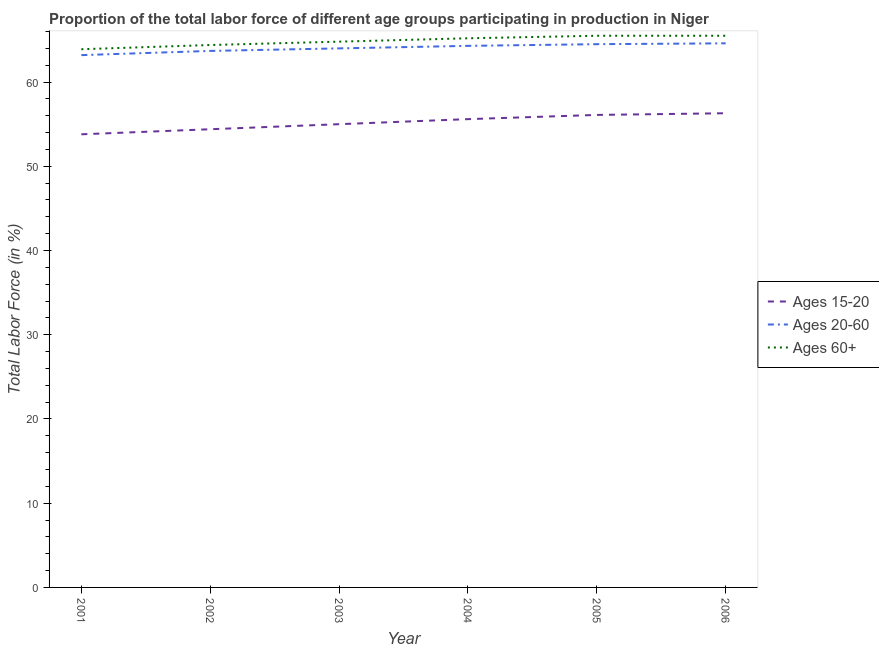Is the number of lines equal to the number of legend labels?
Make the answer very short. Yes. What is the percentage of labor force within the age group 20-60 in 2005?
Your answer should be very brief. 64.5. Across all years, what is the maximum percentage of labor force within the age group 15-20?
Your answer should be compact. 56.3. Across all years, what is the minimum percentage of labor force within the age group 15-20?
Provide a succinct answer. 53.8. In which year was the percentage of labor force above age 60 minimum?
Keep it short and to the point. 2001. What is the total percentage of labor force above age 60 in the graph?
Your response must be concise. 389.3. What is the difference between the percentage of labor force within the age group 20-60 in 2003 and that in 2005?
Make the answer very short. -0.5. What is the difference between the percentage of labor force within the age group 20-60 in 2001 and the percentage of labor force above age 60 in 2002?
Offer a very short reply. -1.2. What is the average percentage of labor force within the age group 15-20 per year?
Keep it short and to the point. 55.2. In the year 2001, what is the difference between the percentage of labor force within the age group 15-20 and percentage of labor force above age 60?
Keep it short and to the point. -10.1. What is the ratio of the percentage of labor force within the age group 20-60 in 2003 to that in 2006?
Your answer should be very brief. 0.99. Is the percentage of labor force above age 60 in 2003 less than that in 2004?
Your response must be concise. Yes. Is the difference between the percentage of labor force within the age group 15-20 in 2002 and 2003 greater than the difference between the percentage of labor force within the age group 20-60 in 2002 and 2003?
Keep it short and to the point. No. What is the difference between the highest and the second highest percentage of labor force within the age group 15-20?
Keep it short and to the point. 0.2. What is the difference between the highest and the lowest percentage of labor force above age 60?
Your answer should be compact. 1.6. Is it the case that in every year, the sum of the percentage of labor force within the age group 15-20 and percentage of labor force within the age group 20-60 is greater than the percentage of labor force above age 60?
Your response must be concise. Yes. Does the percentage of labor force above age 60 monotonically increase over the years?
Your answer should be compact. No. Is the percentage of labor force within the age group 20-60 strictly greater than the percentage of labor force within the age group 15-20 over the years?
Give a very brief answer. Yes. Is the percentage of labor force within the age group 15-20 strictly less than the percentage of labor force within the age group 20-60 over the years?
Offer a very short reply. Yes. Does the graph contain any zero values?
Ensure brevity in your answer.  No. Does the graph contain grids?
Give a very brief answer. No. How are the legend labels stacked?
Provide a succinct answer. Vertical. What is the title of the graph?
Offer a terse response. Proportion of the total labor force of different age groups participating in production in Niger. Does "Non-communicable diseases" appear as one of the legend labels in the graph?
Ensure brevity in your answer.  No. What is the Total Labor Force (in %) of Ages 15-20 in 2001?
Your answer should be very brief. 53.8. What is the Total Labor Force (in %) of Ages 20-60 in 2001?
Offer a very short reply. 63.2. What is the Total Labor Force (in %) in Ages 60+ in 2001?
Give a very brief answer. 63.9. What is the Total Labor Force (in %) of Ages 15-20 in 2002?
Ensure brevity in your answer.  54.4. What is the Total Labor Force (in %) of Ages 20-60 in 2002?
Your answer should be compact. 63.7. What is the Total Labor Force (in %) in Ages 60+ in 2002?
Your answer should be very brief. 64.4. What is the Total Labor Force (in %) in Ages 20-60 in 2003?
Provide a succinct answer. 64. What is the Total Labor Force (in %) of Ages 60+ in 2003?
Provide a short and direct response. 64.8. What is the Total Labor Force (in %) of Ages 15-20 in 2004?
Provide a short and direct response. 55.6. What is the Total Labor Force (in %) of Ages 20-60 in 2004?
Offer a very short reply. 64.3. What is the Total Labor Force (in %) in Ages 60+ in 2004?
Your answer should be very brief. 65.2. What is the Total Labor Force (in %) of Ages 15-20 in 2005?
Your answer should be compact. 56.1. What is the Total Labor Force (in %) of Ages 20-60 in 2005?
Keep it short and to the point. 64.5. What is the Total Labor Force (in %) in Ages 60+ in 2005?
Keep it short and to the point. 65.5. What is the Total Labor Force (in %) in Ages 15-20 in 2006?
Offer a very short reply. 56.3. What is the Total Labor Force (in %) of Ages 20-60 in 2006?
Offer a terse response. 64.6. What is the Total Labor Force (in %) of Ages 60+ in 2006?
Offer a terse response. 65.5. Across all years, what is the maximum Total Labor Force (in %) of Ages 15-20?
Your response must be concise. 56.3. Across all years, what is the maximum Total Labor Force (in %) of Ages 20-60?
Offer a very short reply. 64.6. Across all years, what is the maximum Total Labor Force (in %) of Ages 60+?
Give a very brief answer. 65.5. Across all years, what is the minimum Total Labor Force (in %) of Ages 15-20?
Your answer should be very brief. 53.8. Across all years, what is the minimum Total Labor Force (in %) of Ages 20-60?
Provide a short and direct response. 63.2. Across all years, what is the minimum Total Labor Force (in %) in Ages 60+?
Make the answer very short. 63.9. What is the total Total Labor Force (in %) in Ages 15-20 in the graph?
Provide a short and direct response. 331.2. What is the total Total Labor Force (in %) of Ages 20-60 in the graph?
Your answer should be compact. 384.3. What is the total Total Labor Force (in %) of Ages 60+ in the graph?
Provide a short and direct response. 389.3. What is the difference between the Total Labor Force (in %) of Ages 15-20 in 2001 and that in 2002?
Offer a terse response. -0.6. What is the difference between the Total Labor Force (in %) in Ages 20-60 in 2001 and that in 2002?
Give a very brief answer. -0.5. What is the difference between the Total Labor Force (in %) in Ages 60+ in 2001 and that in 2002?
Provide a succinct answer. -0.5. What is the difference between the Total Labor Force (in %) of Ages 15-20 in 2001 and that in 2003?
Offer a very short reply. -1.2. What is the difference between the Total Labor Force (in %) in Ages 20-60 in 2001 and that in 2003?
Provide a succinct answer. -0.8. What is the difference between the Total Labor Force (in %) of Ages 20-60 in 2001 and that in 2004?
Ensure brevity in your answer.  -1.1. What is the difference between the Total Labor Force (in %) of Ages 20-60 in 2001 and that in 2005?
Provide a short and direct response. -1.3. What is the difference between the Total Labor Force (in %) of Ages 60+ in 2001 and that in 2005?
Your answer should be compact. -1.6. What is the difference between the Total Labor Force (in %) of Ages 15-20 in 2001 and that in 2006?
Your response must be concise. -2.5. What is the difference between the Total Labor Force (in %) in Ages 60+ in 2001 and that in 2006?
Your answer should be very brief. -1.6. What is the difference between the Total Labor Force (in %) of Ages 20-60 in 2002 and that in 2003?
Provide a short and direct response. -0.3. What is the difference between the Total Labor Force (in %) of Ages 60+ in 2002 and that in 2003?
Make the answer very short. -0.4. What is the difference between the Total Labor Force (in %) in Ages 15-20 in 2002 and that in 2004?
Offer a very short reply. -1.2. What is the difference between the Total Labor Force (in %) of Ages 20-60 in 2002 and that in 2004?
Keep it short and to the point. -0.6. What is the difference between the Total Labor Force (in %) in Ages 15-20 in 2002 and that in 2006?
Ensure brevity in your answer.  -1.9. What is the difference between the Total Labor Force (in %) of Ages 60+ in 2002 and that in 2006?
Offer a terse response. -1.1. What is the difference between the Total Labor Force (in %) of Ages 15-20 in 2003 and that in 2004?
Your response must be concise. -0.6. What is the difference between the Total Labor Force (in %) of Ages 60+ in 2003 and that in 2004?
Offer a very short reply. -0.4. What is the difference between the Total Labor Force (in %) of Ages 60+ in 2003 and that in 2005?
Your answer should be very brief. -0.7. What is the difference between the Total Labor Force (in %) of Ages 20-60 in 2003 and that in 2006?
Offer a terse response. -0.6. What is the difference between the Total Labor Force (in %) in Ages 60+ in 2003 and that in 2006?
Provide a succinct answer. -0.7. What is the difference between the Total Labor Force (in %) of Ages 15-20 in 2004 and that in 2005?
Give a very brief answer. -0.5. What is the difference between the Total Labor Force (in %) of Ages 60+ in 2004 and that in 2005?
Offer a very short reply. -0.3. What is the difference between the Total Labor Force (in %) of Ages 20-60 in 2004 and that in 2006?
Provide a succinct answer. -0.3. What is the difference between the Total Labor Force (in %) in Ages 15-20 in 2005 and that in 2006?
Give a very brief answer. -0.2. What is the difference between the Total Labor Force (in %) of Ages 20-60 in 2001 and the Total Labor Force (in %) of Ages 60+ in 2002?
Your answer should be very brief. -1.2. What is the difference between the Total Labor Force (in %) in Ages 15-20 in 2001 and the Total Labor Force (in %) in Ages 60+ in 2003?
Offer a terse response. -11. What is the difference between the Total Labor Force (in %) of Ages 15-20 in 2001 and the Total Labor Force (in %) of Ages 20-60 in 2004?
Keep it short and to the point. -10.5. What is the difference between the Total Labor Force (in %) in Ages 15-20 in 2001 and the Total Labor Force (in %) in Ages 60+ in 2004?
Your answer should be very brief. -11.4. What is the difference between the Total Labor Force (in %) of Ages 20-60 in 2001 and the Total Labor Force (in %) of Ages 60+ in 2004?
Your answer should be compact. -2. What is the difference between the Total Labor Force (in %) in Ages 15-20 in 2001 and the Total Labor Force (in %) in Ages 60+ in 2005?
Provide a short and direct response. -11.7. What is the difference between the Total Labor Force (in %) in Ages 15-20 in 2001 and the Total Labor Force (in %) in Ages 60+ in 2006?
Your answer should be very brief. -11.7. What is the difference between the Total Labor Force (in %) in Ages 20-60 in 2002 and the Total Labor Force (in %) in Ages 60+ in 2003?
Your response must be concise. -1.1. What is the difference between the Total Labor Force (in %) of Ages 15-20 in 2002 and the Total Labor Force (in %) of Ages 20-60 in 2004?
Your answer should be very brief. -9.9. What is the difference between the Total Labor Force (in %) of Ages 15-20 in 2002 and the Total Labor Force (in %) of Ages 60+ in 2004?
Keep it short and to the point. -10.8. What is the difference between the Total Labor Force (in %) in Ages 15-20 in 2002 and the Total Labor Force (in %) in Ages 60+ in 2005?
Provide a succinct answer. -11.1. What is the difference between the Total Labor Force (in %) of Ages 20-60 in 2002 and the Total Labor Force (in %) of Ages 60+ in 2005?
Keep it short and to the point. -1.8. What is the difference between the Total Labor Force (in %) in Ages 15-20 in 2002 and the Total Labor Force (in %) in Ages 20-60 in 2006?
Make the answer very short. -10.2. What is the difference between the Total Labor Force (in %) in Ages 15-20 in 2002 and the Total Labor Force (in %) in Ages 60+ in 2006?
Give a very brief answer. -11.1. What is the difference between the Total Labor Force (in %) in Ages 15-20 in 2003 and the Total Labor Force (in %) in Ages 20-60 in 2004?
Give a very brief answer. -9.3. What is the difference between the Total Labor Force (in %) in Ages 15-20 in 2003 and the Total Labor Force (in %) in Ages 60+ in 2004?
Ensure brevity in your answer.  -10.2. What is the difference between the Total Labor Force (in %) of Ages 20-60 in 2003 and the Total Labor Force (in %) of Ages 60+ in 2005?
Ensure brevity in your answer.  -1.5. What is the difference between the Total Labor Force (in %) in Ages 20-60 in 2003 and the Total Labor Force (in %) in Ages 60+ in 2006?
Offer a terse response. -1.5. What is the difference between the Total Labor Force (in %) of Ages 15-20 in 2004 and the Total Labor Force (in %) of Ages 20-60 in 2005?
Ensure brevity in your answer.  -8.9. What is the difference between the Total Labor Force (in %) in Ages 15-20 in 2004 and the Total Labor Force (in %) in Ages 60+ in 2005?
Offer a terse response. -9.9. What is the difference between the Total Labor Force (in %) in Ages 20-60 in 2004 and the Total Labor Force (in %) in Ages 60+ in 2005?
Your answer should be compact. -1.2. What is the difference between the Total Labor Force (in %) in Ages 15-20 in 2004 and the Total Labor Force (in %) in Ages 20-60 in 2006?
Your answer should be compact. -9. What is the difference between the Total Labor Force (in %) of Ages 20-60 in 2004 and the Total Labor Force (in %) of Ages 60+ in 2006?
Your answer should be very brief. -1.2. What is the difference between the Total Labor Force (in %) of Ages 15-20 in 2005 and the Total Labor Force (in %) of Ages 60+ in 2006?
Provide a succinct answer. -9.4. What is the average Total Labor Force (in %) in Ages 15-20 per year?
Your answer should be very brief. 55.2. What is the average Total Labor Force (in %) of Ages 20-60 per year?
Keep it short and to the point. 64.05. What is the average Total Labor Force (in %) in Ages 60+ per year?
Offer a very short reply. 64.88. In the year 2001, what is the difference between the Total Labor Force (in %) of Ages 15-20 and Total Labor Force (in %) of Ages 20-60?
Keep it short and to the point. -9.4. In the year 2001, what is the difference between the Total Labor Force (in %) in Ages 15-20 and Total Labor Force (in %) in Ages 60+?
Provide a short and direct response. -10.1. In the year 2001, what is the difference between the Total Labor Force (in %) of Ages 20-60 and Total Labor Force (in %) of Ages 60+?
Make the answer very short. -0.7. In the year 2002, what is the difference between the Total Labor Force (in %) of Ages 15-20 and Total Labor Force (in %) of Ages 20-60?
Ensure brevity in your answer.  -9.3. In the year 2002, what is the difference between the Total Labor Force (in %) of Ages 20-60 and Total Labor Force (in %) of Ages 60+?
Give a very brief answer. -0.7. In the year 2003, what is the difference between the Total Labor Force (in %) of Ages 15-20 and Total Labor Force (in %) of Ages 20-60?
Keep it short and to the point. -9. In the year 2003, what is the difference between the Total Labor Force (in %) of Ages 20-60 and Total Labor Force (in %) of Ages 60+?
Give a very brief answer. -0.8. In the year 2004, what is the difference between the Total Labor Force (in %) of Ages 15-20 and Total Labor Force (in %) of Ages 20-60?
Keep it short and to the point. -8.7. In the year 2004, what is the difference between the Total Labor Force (in %) of Ages 15-20 and Total Labor Force (in %) of Ages 60+?
Offer a very short reply. -9.6. In the year 2006, what is the difference between the Total Labor Force (in %) of Ages 15-20 and Total Labor Force (in %) of Ages 20-60?
Provide a succinct answer. -8.3. In the year 2006, what is the difference between the Total Labor Force (in %) of Ages 15-20 and Total Labor Force (in %) of Ages 60+?
Provide a succinct answer. -9.2. What is the ratio of the Total Labor Force (in %) of Ages 15-20 in 2001 to that in 2002?
Your response must be concise. 0.99. What is the ratio of the Total Labor Force (in %) in Ages 20-60 in 2001 to that in 2002?
Offer a very short reply. 0.99. What is the ratio of the Total Labor Force (in %) in Ages 60+ in 2001 to that in 2002?
Make the answer very short. 0.99. What is the ratio of the Total Labor Force (in %) of Ages 15-20 in 2001 to that in 2003?
Ensure brevity in your answer.  0.98. What is the ratio of the Total Labor Force (in %) of Ages 20-60 in 2001 to that in 2003?
Offer a terse response. 0.99. What is the ratio of the Total Labor Force (in %) of Ages 60+ in 2001 to that in 2003?
Your answer should be very brief. 0.99. What is the ratio of the Total Labor Force (in %) in Ages 15-20 in 2001 to that in 2004?
Your response must be concise. 0.97. What is the ratio of the Total Labor Force (in %) of Ages 20-60 in 2001 to that in 2004?
Make the answer very short. 0.98. What is the ratio of the Total Labor Force (in %) of Ages 60+ in 2001 to that in 2004?
Provide a short and direct response. 0.98. What is the ratio of the Total Labor Force (in %) in Ages 15-20 in 2001 to that in 2005?
Your response must be concise. 0.96. What is the ratio of the Total Labor Force (in %) of Ages 20-60 in 2001 to that in 2005?
Your answer should be compact. 0.98. What is the ratio of the Total Labor Force (in %) in Ages 60+ in 2001 to that in 2005?
Your response must be concise. 0.98. What is the ratio of the Total Labor Force (in %) in Ages 15-20 in 2001 to that in 2006?
Provide a short and direct response. 0.96. What is the ratio of the Total Labor Force (in %) in Ages 20-60 in 2001 to that in 2006?
Your answer should be very brief. 0.98. What is the ratio of the Total Labor Force (in %) in Ages 60+ in 2001 to that in 2006?
Provide a succinct answer. 0.98. What is the ratio of the Total Labor Force (in %) in Ages 15-20 in 2002 to that in 2003?
Offer a very short reply. 0.99. What is the ratio of the Total Labor Force (in %) in Ages 20-60 in 2002 to that in 2003?
Keep it short and to the point. 1. What is the ratio of the Total Labor Force (in %) of Ages 15-20 in 2002 to that in 2004?
Provide a short and direct response. 0.98. What is the ratio of the Total Labor Force (in %) in Ages 20-60 in 2002 to that in 2004?
Provide a short and direct response. 0.99. What is the ratio of the Total Labor Force (in %) in Ages 15-20 in 2002 to that in 2005?
Your answer should be compact. 0.97. What is the ratio of the Total Labor Force (in %) of Ages 20-60 in 2002 to that in 2005?
Your answer should be compact. 0.99. What is the ratio of the Total Labor Force (in %) of Ages 60+ in 2002 to that in 2005?
Keep it short and to the point. 0.98. What is the ratio of the Total Labor Force (in %) of Ages 15-20 in 2002 to that in 2006?
Ensure brevity in your answer.  0.97. What is the ratio of the Total Labor Force (in %) in Ages 20-60 in 2002 to that in 2006?
Give a very brief answer. 0.99. What is the ratio of the Total Labor Force (in %) of Ages 60+ in 2002 to that in 2006?
Your answer should be compact. 0.98. What is the ratio of the Total Labor Force (in %) of Ages 20-60 in 2003 to that in 2004?
Keep it short and to the point. 1. What is the ratio of the Total Labor Force (in %) of Ages 60+ in 2003 to that in 2004?
Provide a short and direct response. 0.99. What is the ratio of the Total Labor Force (in %) in Ages 15-20 in 2003 to that in 2005?
Keep it short and to the point. 0.98. What is the ratio of the Total Labor Force (in %) of Ages 60+ in 2003 to that in 2005?
Make the answer very short. 0.99. What is the ratio of the Total Labor Force (in %) in Ages 15-20 in 2003 to that in 2006?
Your answer should be very brief. 0.98. What is the ratio of the Total Labor Force (in %) in Ages 20-60 in 2003 to that in 2006?
Give a very brief answer. 0.99. What is the ratio of the Total Labor Force (in %) in Ages 60+ in 2003 to that in 2006?
Provide a succinct answer. 0.99. What is the ratio of the Total Labor Force (in %) of Ages 20-60 in 2004 to that in 2005?
Keep it short and to the point. 1. What is the ratio of the Total Labor Force (in %) of Ages 60+ in 2004 to that in 2005?
Keep it short and to the point. 1. What is the ratio of the Total Labor Force (in %) in Ages 15-20 in 2004 to that in 2006?
Offer a very short reply. 0.99. What is the ratio of the Total Labor Force (in %) in Ages 60+ in 2004 to that in 2006?
Provide a short and direct response. 1. What is the ratio of the Total Labor Force (in %) of Ages 60+ in 2005 to that in 2006?
Provide a succinct answer. 1. What is the difference between the highest and the lowest Total Labor Force (in %) in Ages 15-20?
Offer a very short reply. 2.5. 